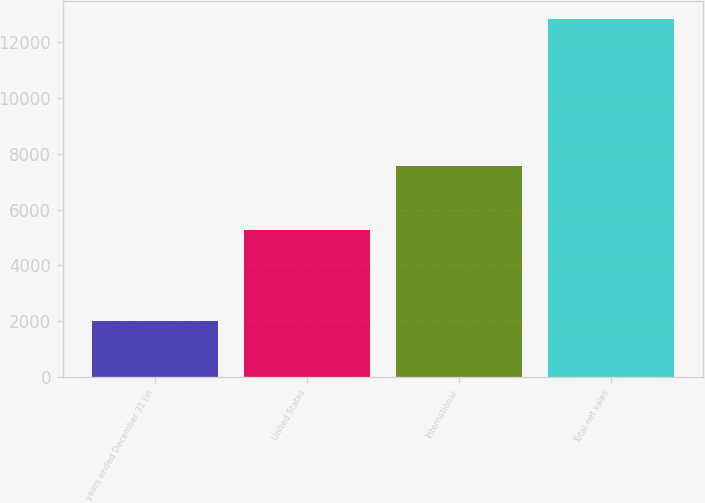Convert chart to OTSL. <chart><loc_0><loc_0><loc_500><loc_500><bar_chart><fcel>years ended December 31 (in<fcel>United States<fcel>International<fcel>Total net sales<nl><fcel>2010<fcel>5264<fcel>7579<fcel>12843<nl></chart> 